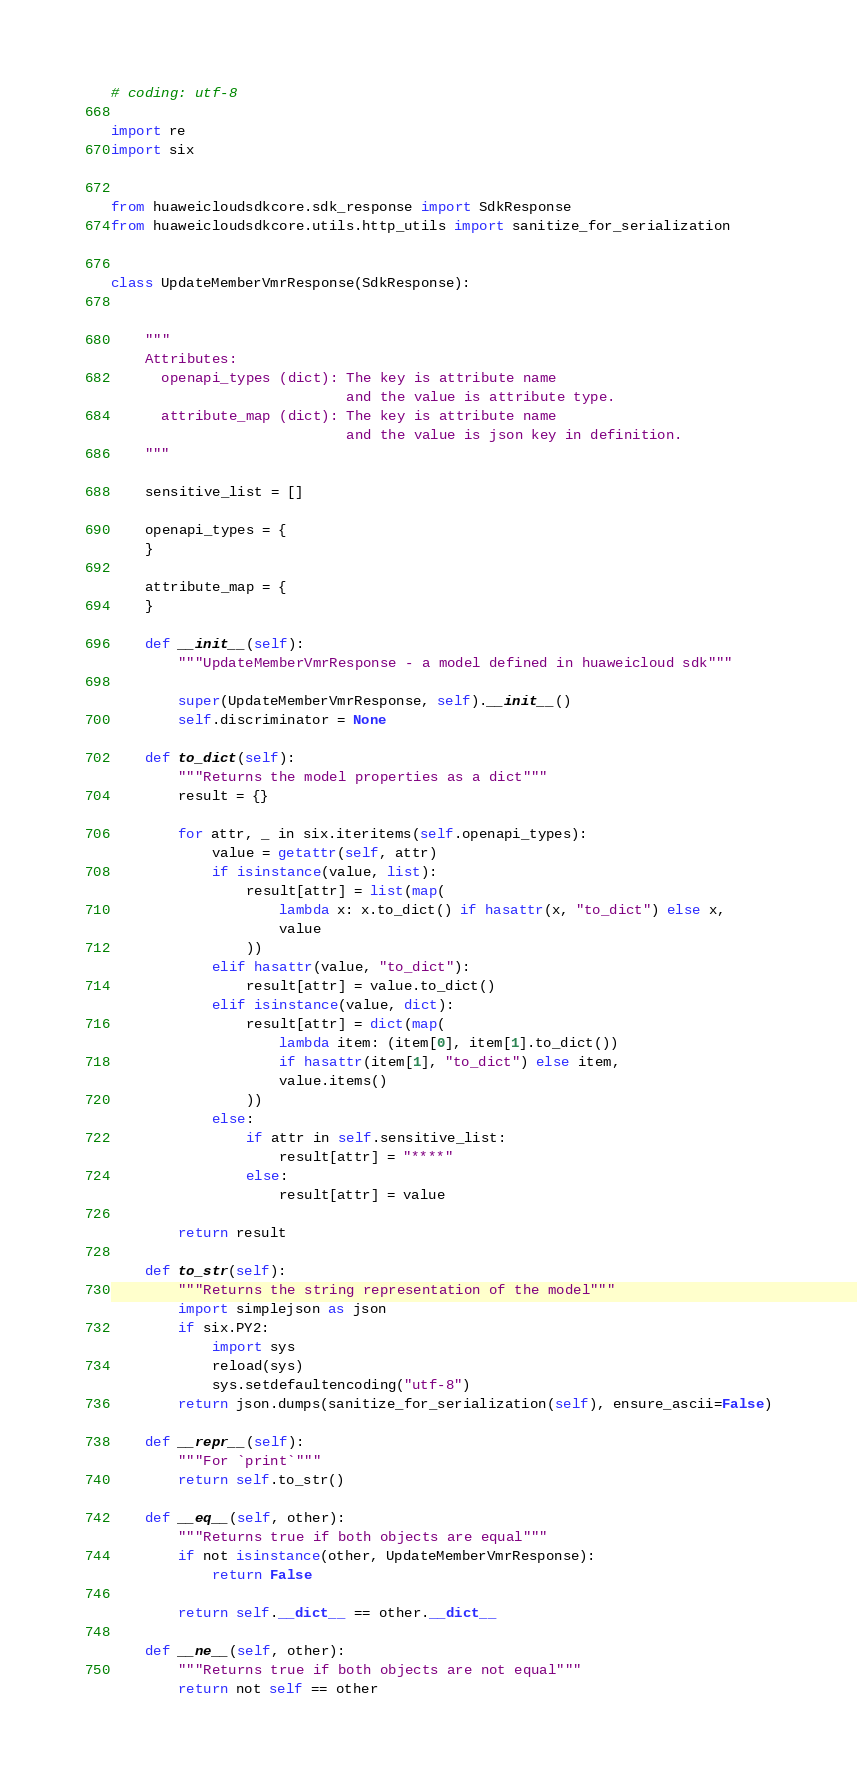Convert code to text. <code><loc_0><loc_0><loc_500><loc_500><_Python_># coding: utf-8

import re
import six


from huaweicloudsdkcore.sdk_response import SdkResponse
from huaweicloudsdkcore.utils.http_utils import sanitize_for_serialization


class UpdateMemberVmrResponse(SdkResponse):


    """
    Attributes:
      openapi_types (dict): The key is attribute name
                            and the value is attribute type.
      attribute_map (dict): The key is attribute name
                            and the value is json key in definition.
    """

    sensitive_list = []

    openapi_types = {
    }

    attribute_map = {
    }

    def __init__(self):
        """UpdateMemberVmrResponse - a model defined in huaweicloud sdk"""
        
        super(UpdateMemberVmrResponse, self).__init__()
        self.discriminator = None

    def to_dict(self):
        """Returns the model properties as a dict"""
        result = {}

        for attr, _ in six.iteritems(self.openapi_types):
            value = getattr(self, attr)
            if isinstance(value, list):
                result[attr] = list(map(
                    lambda x: x.to_dict() if hasattr(x, "to_dict") else x,
                    value
                ))
            elif hasattr(value, "to_dict"):
                result[attr] = value.to_dict()
            elif isinstance(value, dict):
                result[attr] = dict(map(
                    lambda item: (item[0], item[1].to_dict())
                    if hasattr(item[1], "to_dict") else item,
                    value.items()
                ))
            else:
                if attr in self.sensitive_list:
                    result[attr] = "****"
                else:
                    result[attr] = value

        return result

    def to_str(self):
        """Returns the string representation of the model"""
        import simplejson as json
        if six.PY2:
            import sys
            reload(sys)
            sys.setdefaultencoding("utf-8")
        return json.dumps(sanitize_for_serialization(self), ensure_ascii=False)

    def __repr__(self):
        """For `print`"""
        return self.to_str()

    def __eq__(self, other):
        """Returns true if both objects are equal"""
        if not isinstance(other, UpdateMemberVmrResponse):
            return False

        return self.__dict__ == other.__dict__

    def __ne__(self, other):
        """Returns true if both objects are not equal"""
        return not self == other
</code> 